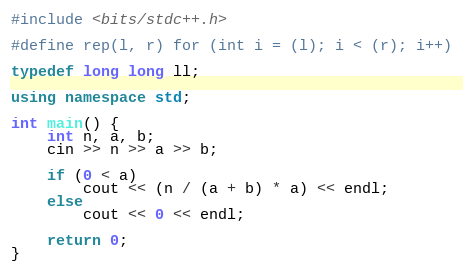Convert code to text. <code><loc_0><loc_0><loc_500><loc_500><_C++_>#include <bits/stdc++.h>

#define rep(l, r) for (int i = (l); i < (r); i++)

typedef long long ll;
 
using namespace std;

int main() {
    int n, a, b;
    cin >> n >> a >> b;

    if (0 < a)
        cout << (n / (a + b) * a) << endl;
    else
        cout << 0 << endl;

    return 0;
}
</code> 